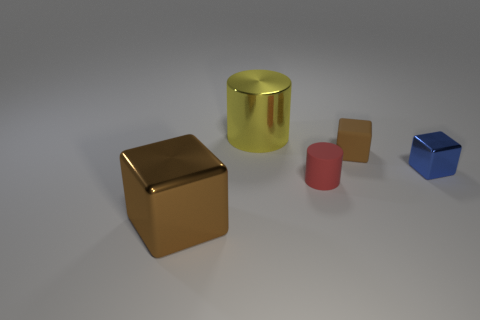Subtract all matte blocks. How many blocks are left? 2 Subtract all yellow balls. How many brown blocks are left? 2 Add 4 big red matte cubes. How many objects exist? 9 Subtract 1 cylinders. How many cylinders are left? 1 Subtract all red cylinders. How many cylinders are left? 1 Subtract all cubes. How many objects are left? 2 Add 1 tiny red rubber cylinders. How many tiny red rubber cylinders are left? 2 Add 5 large metallic spheres. How many large metallic spheres exist? 5 Subtract 0 gray spheres. How many objects are left? 5 Subtract all cyan cylinders. Subtract all blue blocks. How many cylinders are left? 2 